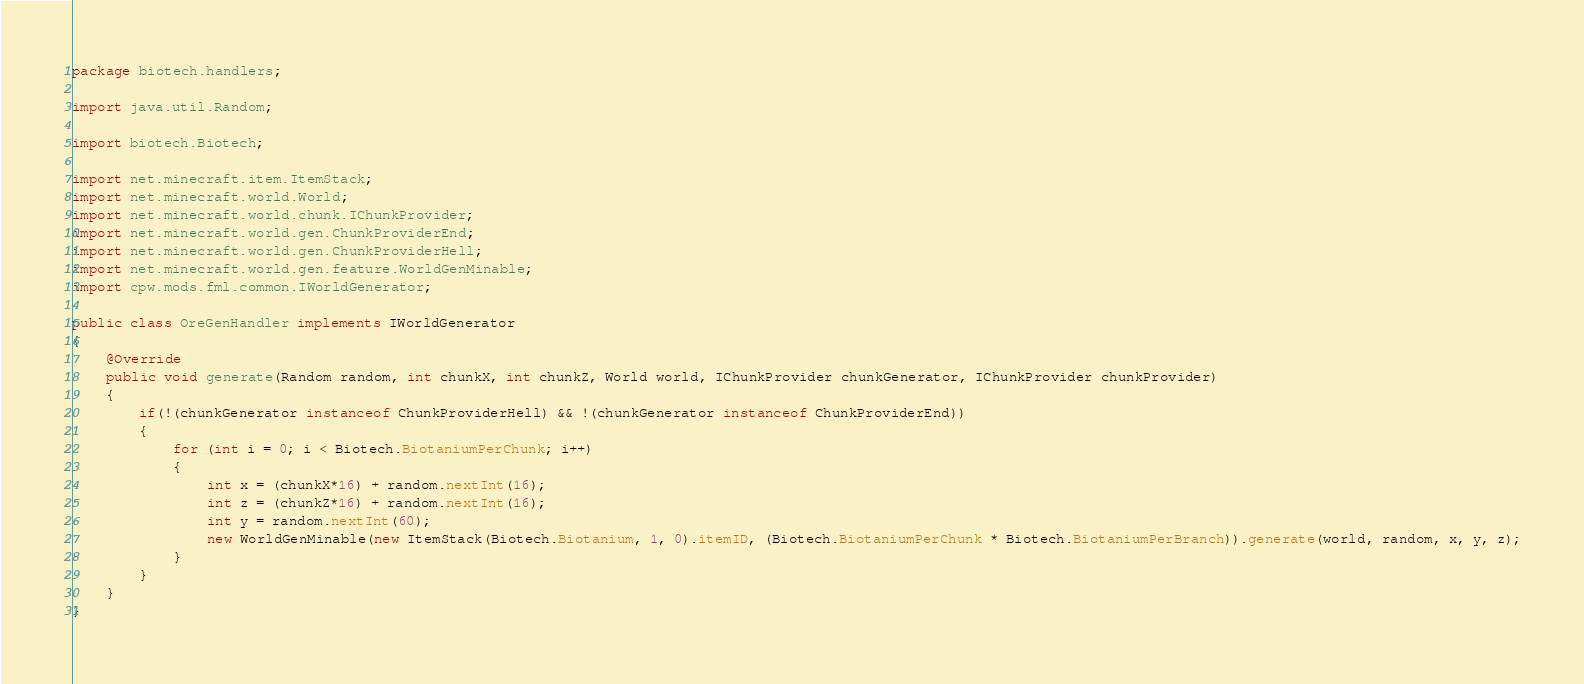<code> <loc_0><loc_0><loc_500><loc_500><_Java_>package biotech.handlers;

import java.util.Random;

import biotech.Biotech;

import net.minecraft.item.ItemStack;
import net.minecraft.world.World;
import net.minecraft.world.chunk.IChunkProvider;
import net.minecraft.world.gen.ChunkProviderEnd;
import net.minecraft.world.gen.ChunkProviderHell;
import net.minecraft.world.gen.feature.WorldGenMinable;
import cpw.mods.fml.common.IWorldGenerator;

public class OreGenHandler implements IWorldGenerator
{
	@Override
	public void generate(Random random, int chunkX, int chunkZ, World world, IChunkProvider chunkGenerator, IChunkProvider chunkProvider) 
	{		
		if(!(chunkGenerator instanceof ChunkProviderHell) && !(chunkGenerator instanceof ChunkProviderEnd))
		{
			for (int i = 0; i < Biotech.BiotaniumPerChunk; i++)
			{
				int x = (chunkX*16) + random.nextInt(16);
				int z = (chunkZ*16) + random.nextInt(16);
				int y = random.nextInt(60);
				new WorldGenMinable(new ItemStack(Biotech.Biotanium, 1, 0).itemID, (Biotech.BiotaniumPerChunk * Biotech.BiotaniumPerBranch)).generate(world, random, x, y, z);
			}
		}
	}	
}
</code> 